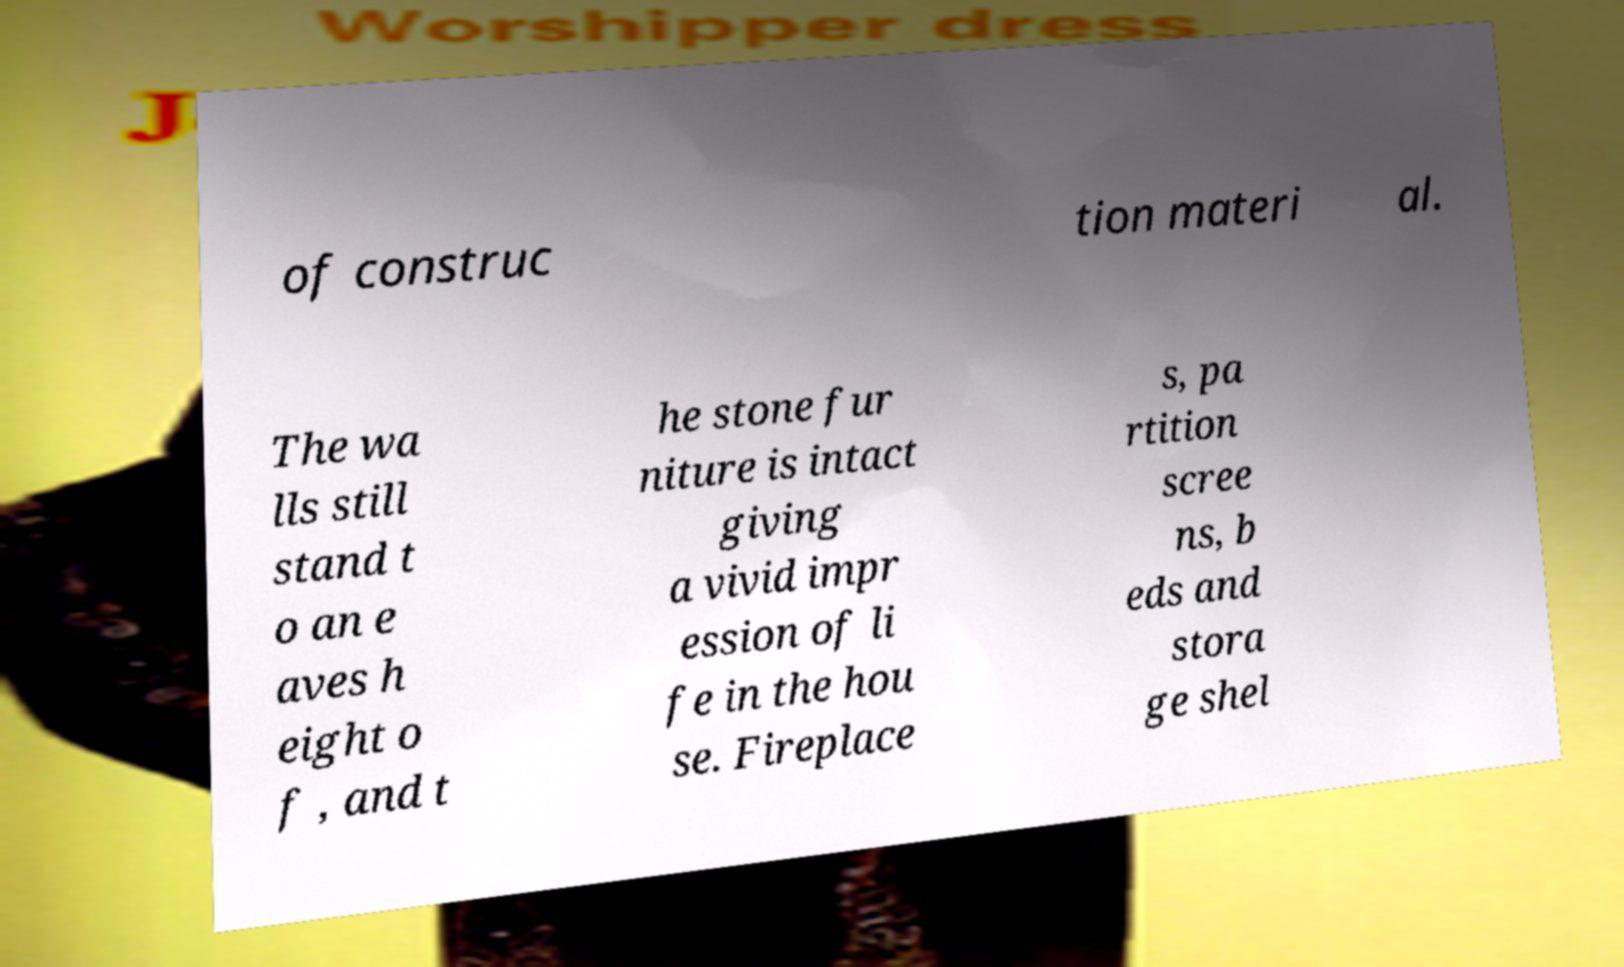Could you extract and type out the text from this image? of construc tion materi al. The wa lls still stand t o an e aves h eight o f , and t he stone fur niture is intact giving a vivid impr ession of li fe in the hou se. Fireplace s, pa rtition scree ns, b eds and stora ge shel 